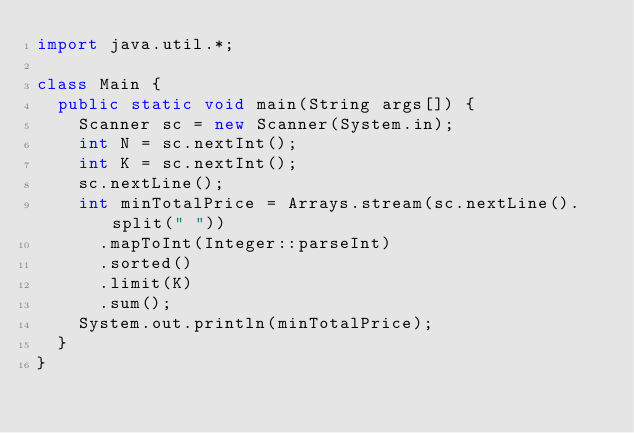<code> <loc_0><loc_0><loc_500><loc_500><_Java_>import java.util.*;

class Main {
  public static void main(String args[]) {
    Scanner sc = new Scanner(System.in);
    int N = sc.nextInt();
    int K = sc.nextInt();
    sc.nextLine();
    int minTotalPrice = Arrays.stream(sc.nextLine().split(" "))
      .mapToInt(Integer::parseInt)
      .sorted()
      .limit(K) 
      .sum();
    System.out.println(minTotalPrice);
  }
}</code> 